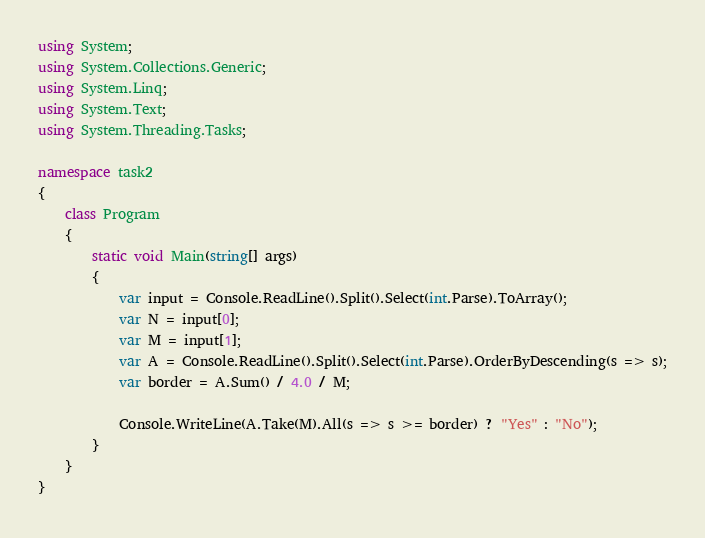<code> <loc_0><loc_0><loc_500><loc_500><_C#_>using System;
using System.Collections.Generic;
using System.Linq;
using System.Text;
using System.Threading.Tasks;

namespace task2
{
    class Program
    {
        static void Main(string[] args)
        {
            var input = Console.ReadLine().Split().Select(int.Parse).ToArray();
            var N = input[0];
            var M = input[1];
            var A = Console.ReadLine().Split().Select(int.Parse).OrderByDescending(s => s);
            var border = A.Sum() / 4.0 / M;

            Console.WriteLine(A.Take(M).All(s => s >= border) ? "Yes" : "No");
        }
    }
}
</code> 